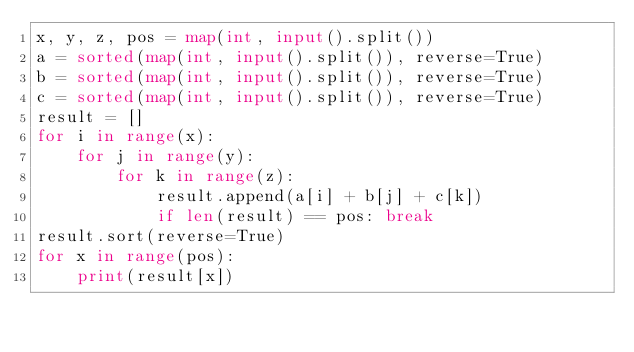<code> <loc_0><loc_0><loc_500><loc_500><_Python_>x, y, z, pos = map(int, input().split())
a = sorted(map(int, input().split()), reverse=True)
b = sorted(map(int, input().split()), reverse=True)
c = sorted(map(int, input().split()), reverse=True)
result = []
for i in range(x):
    for j in range(y):
        for k in range(z):
            result.append(a[i] + b[j] + c[k])
            if len(result) == pos: break
result.sort(reverse=True)
for x in range(pos):
    print(result[x])</code> 